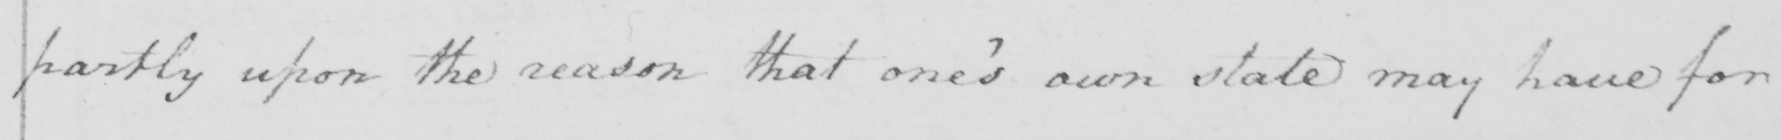What does this handwritten line say? partly upon the reason that one ' s own state may have for 